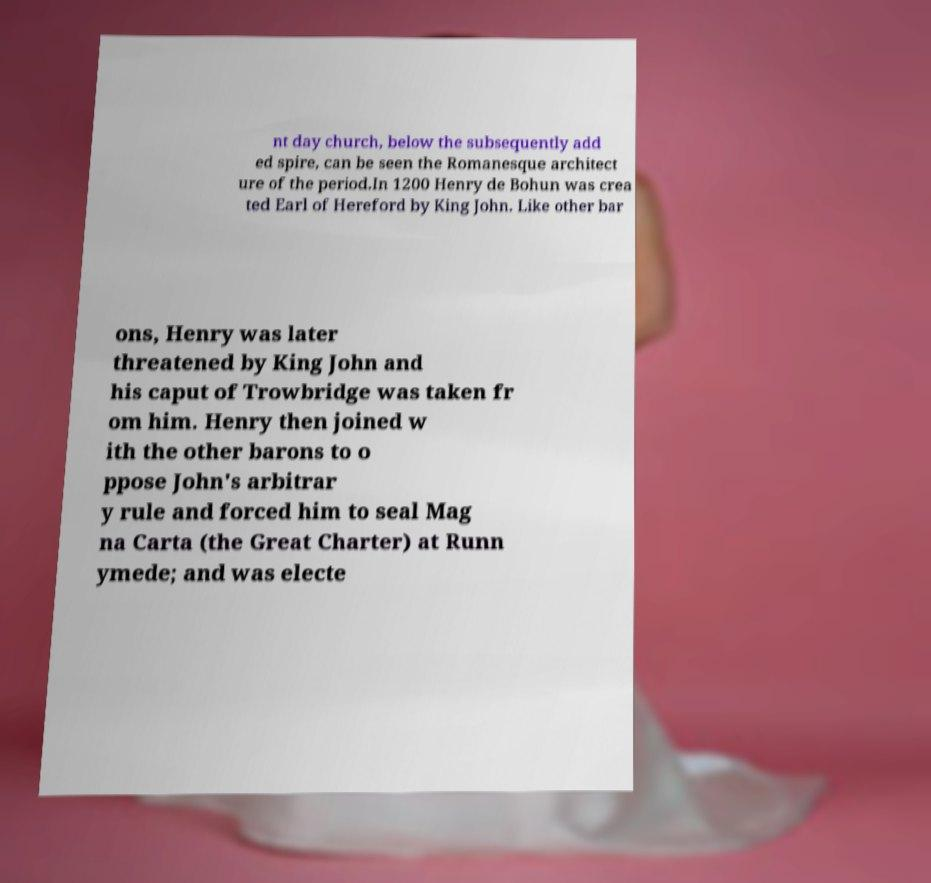Please read and relay the text visible in this image. What does it say? nt day church, below the subsequently add ed spire, can be seen the Romanesque architect ure of the period.In 1200 Henry de Bohun was crea ted Earl of Hereford by King John. Like other bar ons, Henry was later threatened by King John and his caput of Trowbridge was taken fr om him. Henry then joined w ith the other barons to o ppose John's arbitrar y rule and forced him to seal Mag na Carta (the Great Charter) at Runn ymede; and was electe 